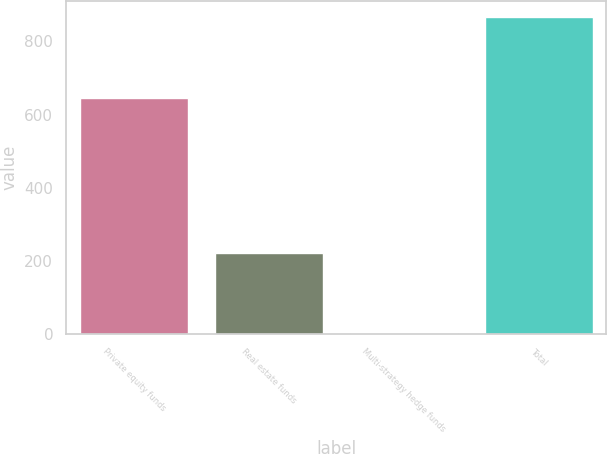Convert chart. <chart><loc_0><loc_0><loc_500><loc_500><bar_chart><fcel>Private equity funds<fcel>Real estate funds<fcel>Multi-strategy hedge funds<fcel>Total<nl><fcel>644<fcel>221<fcel>3<fcel>868<nl></chart> 